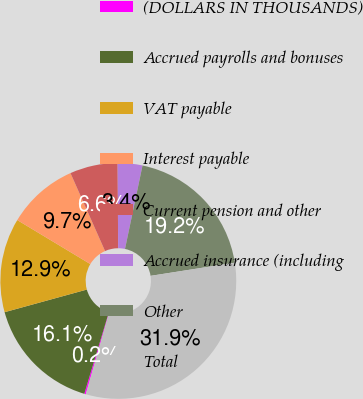<chart> <loc_0><loc_0><loc_500><loc_500><pie_chart><fcel>(DOLLARS IN THOUSANDS)<fcel>Accrued payrolls and bonuses<fcel>VAT payable<fcel>Interest payable<fcel>Current pension and other<fcel>Accrued insurance (including<fcel>Other<fcel>Total<nl><fcel>0.21%<fcel>16.07%<fcel>12.9%<fcel>9.73%<fcel>6.56%<fcel>3.38%<fcel>19.24%<fcel>31.92%<nl></chart> 